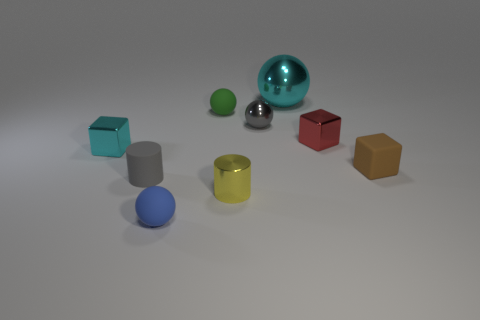Subtract 1 spheres. How many spheres are left? 3 Add 1 tiny gray metal balls. How many objects exist? 10 Subtract all balls. How many objects are left? 5 Subtract all small red matte blocks. Subtract all big cyan balls. How many objects are left? 8 Add 8 big things. How many big things are left? 9 Add 7 tiny matte cylinders. How many tiny matte cylinders exist? 8 Subtract 0 green cylinders. How many objects are left? 9 